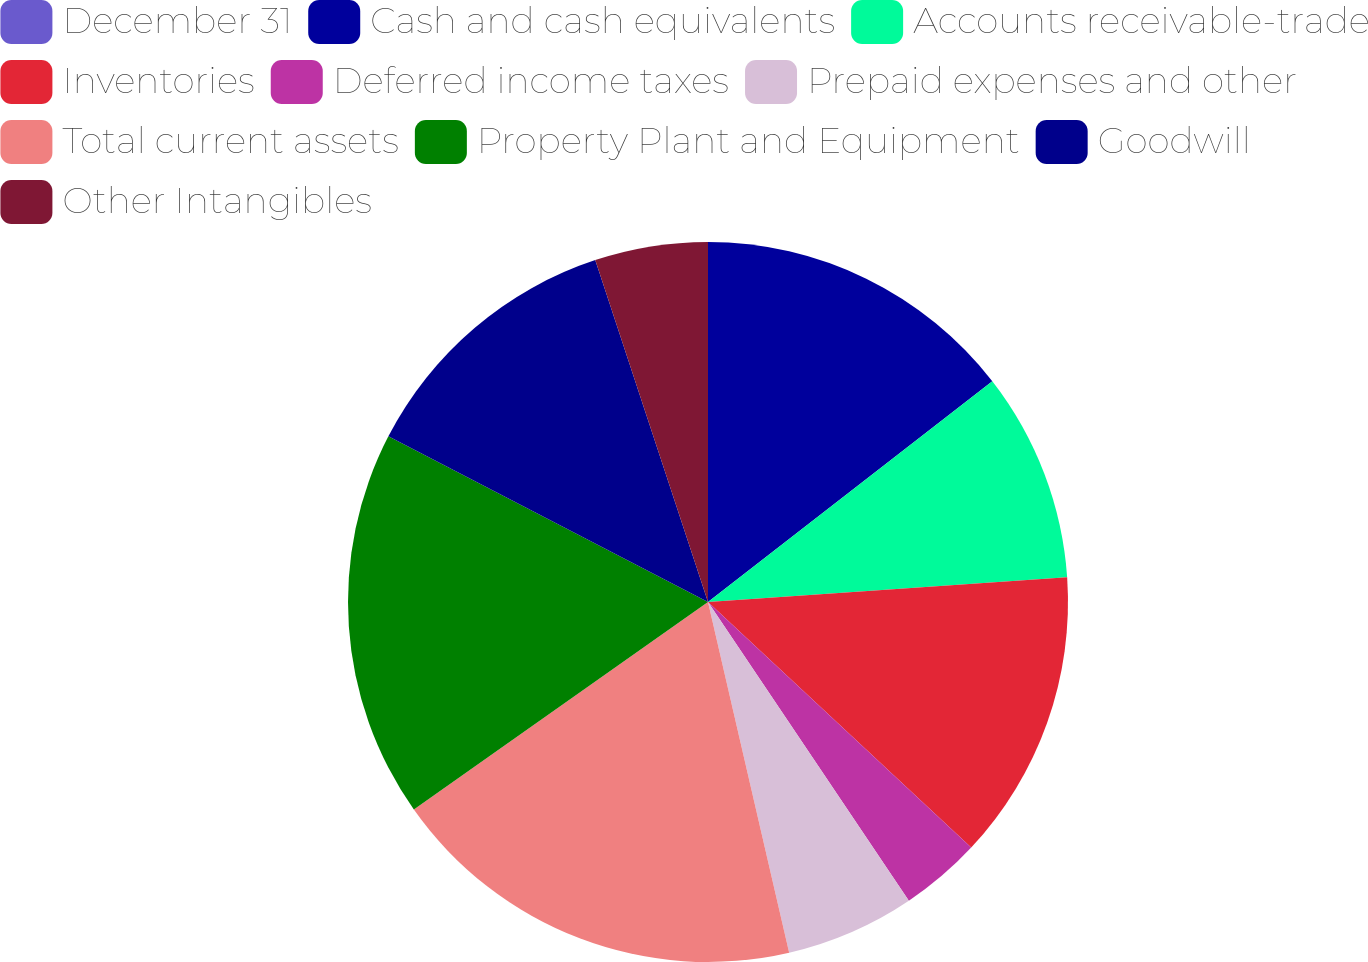<chart> <loc_0><loc_0><loc_500><loc_500><pie_chart><fcel>December 31<fcel>Cash and cash equivalents<fcel>Accounts receivable-trade<fcel>Inventories<fcel>Deferred income taxes<fcel>Prepaid expenses and other<fcel>Total current assets<fcel>Property Plant and Equipment<fcel>Goodwill<fcel>Other Intangibles<nl><fcel>0.0%<fcel>14.49%<fcel>9.42%<fcel>13.04%<fcel>3.63%<fcel>5.8%<fcel>18.84%<fcel>17.39%<fcel>12.32%<fcel>5.07%<nl></chart> 